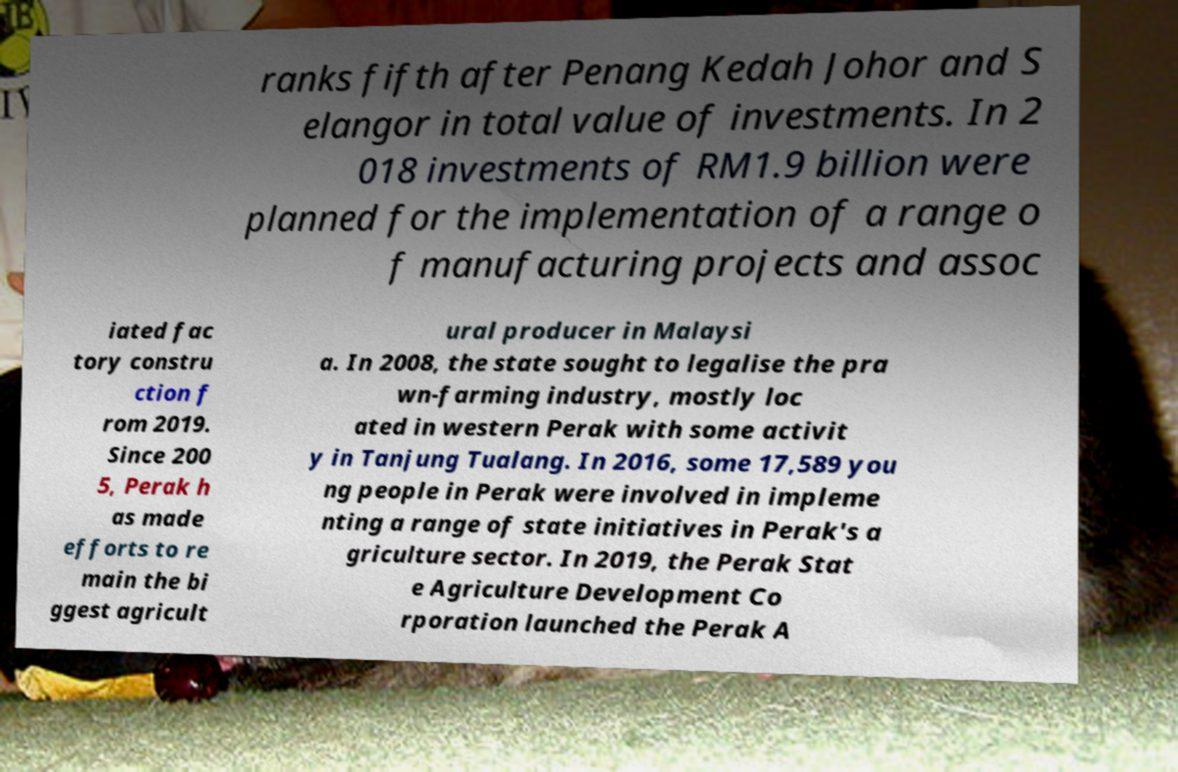I need the written content from this picture converted into text. Can you do that? ranks fifth after Penang Kedah Johor and S elangor in total value of investments. In 2 018 investments of RM1.9 billion were planned for the implementation of a range o f manufacturing projects and assoc iated fac tory constru ction f rom 2019. Since 200 5, Perak h as made efforts to re main the bi ggest agricult ural producer in Malaysi a. In 2008, the state sought to legalise the pra wn-farming industry, mostly loc ated in western Perak with some activit y in Tanjung Tualang. In 2016, some 17,589 you ng people in Perak were involved in impleme nting a range of state initiatives in Perak's a griculture sector. In 2019, the Perak Stat e Agriculture Development Co rporation launched the Perak A 